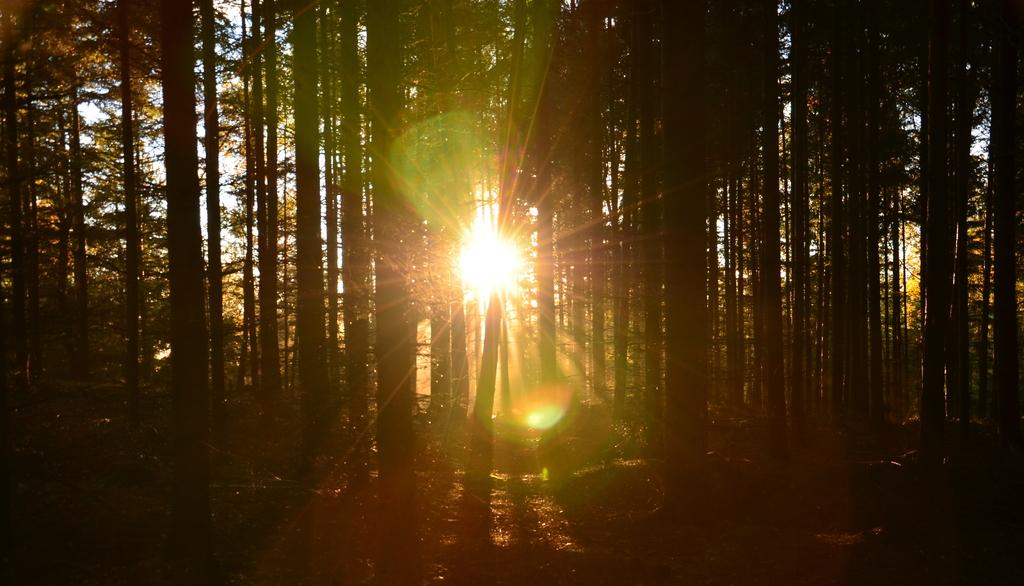What type of vegetation can be seen in the image? There are trees in the image. What celestial body is visible in the image? The sun is visible in the image. What scientific discovery can be observed in the image? There is no scientific discovery present in the image; it features trees and the sun. What type of bone is visible in the image? There is no bone present in the image. 